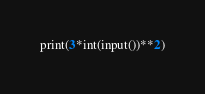<code> <loc_0><loc_0><loc_500><loc_500><_Python_>print(3*int(input())**2)</code> 